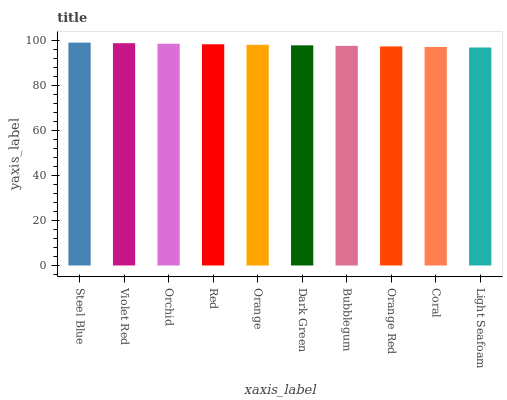Is Light Seafoam the minimum?
Answer yes or no. Yes. Is Steel Blue the maximum?
Answer yes or no. Yes. Is Violet Red the minimum?
Answer yes or no. No. Is Violet Red the maximum?
Answer yes or no. No. Is Steel Blue greater than Violet Red?
Answer yes or no. Yes. Is Violet Red less than Steel Blue?
Answer yes or no. Yes. Is Violet Red greater than Steel Blue?
Answer yes or no. No. Is Steel Blue less than Violet Red?
Answer yes or no. No. Is Orange the high median?
Answer yes or no. Yes. Is Dark Green the low median?
Answer yes or no. Yes. Is Light Seafoam the high median?
Answer yes or no. No. Is Orchid the low median?
Answer yes or no. No. 